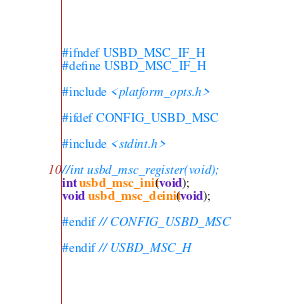<code> <loc_0><loc_0><loc_500><loc_500><_C_>#ifndef USBD_MSC_IF_H
#define USBD_MSC_IF_H

#include <platform_opts.h>

#ifdef CONFIG_USBD_MSC

#include <stdint.h>

//int usbd_msc_register(void);
int usbd_msc_init(void);
void usbd_msc_deinit(void);

#endif // CONFIG_USBD_MSC

#endif // USBD_MSC_H</code> 